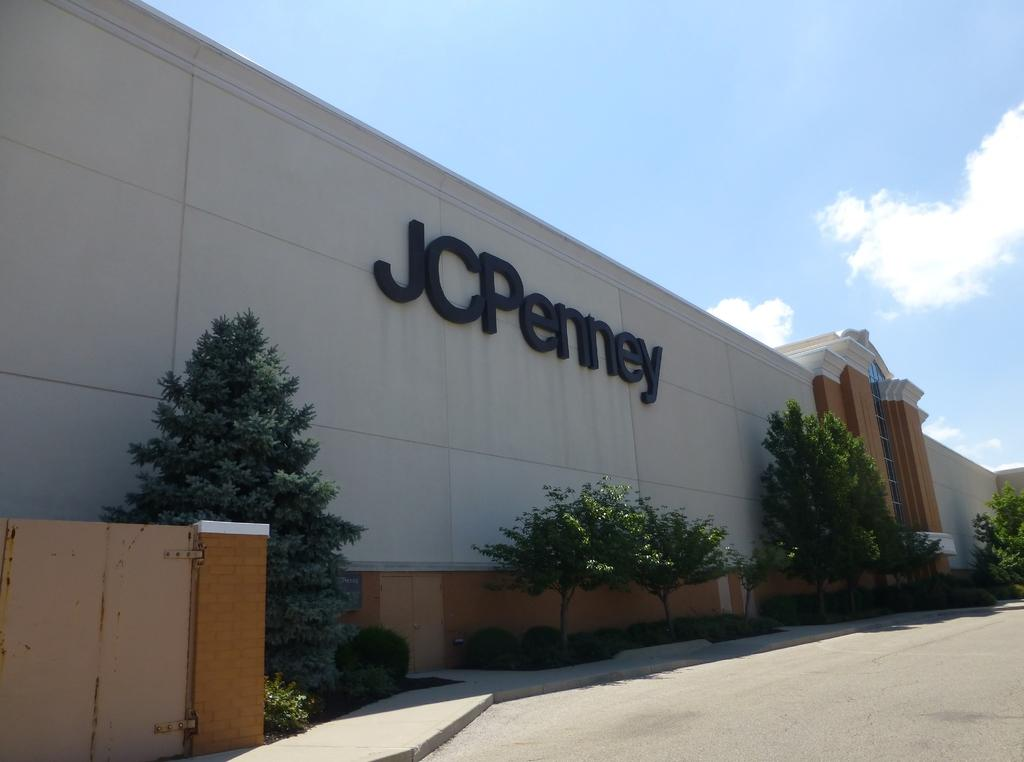What is the main structure in the center of the image? There is a building in the center of the image. What type of vegetation can be seen in the image? There are trees and bushes in the image. What is the entrance to the building in the image? There is a gate in the image. What is at the bottom of the image? There is a road at the bottom of the image. What is visible at the top of the image? The sky is visible at the top of the image. How many houses are visible on the island in the image? There is no island or houses present in the image. What color is the sweater worn by the person in the image? There is no person or sweater present in the image. 